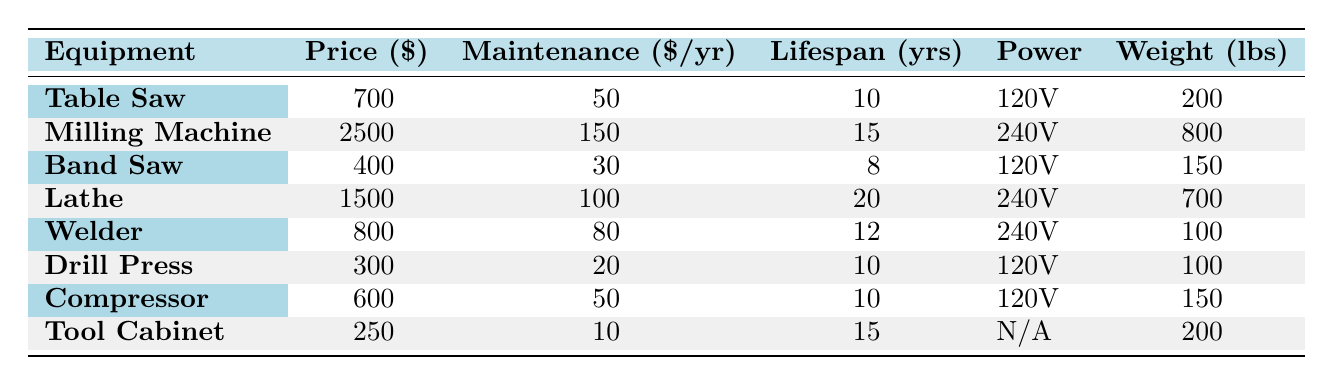What is the price of the Milling Machine? The table lists the price under the "Price ($)" column for each equipment. For the Milling Machine, the price is clearly shown as $2500.
Answer: 2500 Which equipment has the highest maintenance cost per year? To find the highest maintenance cost, we look at the "Maintenance ($/yr)" column for all the equipment. The Milling Machine has the highest maintenance cost of $150 per year.
Answer: Milling Machine What is the average lifespan of all the equipment listed? To calculate the average lifespan, sum the "Lifespan (yrs)" values: 10 + 15 + 8 + 20 + 12 + 10 + 10 + 15 = 100. Then divide the total by the number of equipment (8): 100 / 8 = 12.5 years.
Answer: 12.5 Is the Welder heavier than the Band Saw? Compare the "Weight (lbs)" column for both the Welder and the Band Saw. The Welder weighs 100 lbs and the Band Saw weighs 150 lbs. Since 100 is less than 150, the Welder is not heavier.
Answer: No What is the total maintenance cost per year for all the equipment? To find the total maintenance cost, sum all the "Maintenance ($/yr)" values: 50 + 150 + 30 + 100 + 80 + 20 + 50 + 10 = 490. This gives the total maintenance cost per year for all eight pieces of equipment.
Answer: 490 Which equipment has the longest usage lifespan? Check the "Lifespan (yrs)" column for the maximum value. The Lathe has the longest lifespan at 20 years, which is greater than any other equipment.
Answer: Lathe Which equipment requires 120V power and what is its weight? Identify the equipment with 120V in the "Power" column. The Table Saw, Band Saw, Drill Press, and Compressor use 120V. Their respective weights are 200 lbs, 150 lbs, 100 lbs, and 150 lbs.
Answer: Table Saw: 200 lbs, Band Saw: 150 lbs, Drill Press: 100 lbs, Compressor: 150 lbs Does the Tool Cabinet require any power? The "Power" column for the Tool Cabinet shows "N/A," indicating it does not require power. Thus, it does not require any power.
Answer: Yes 